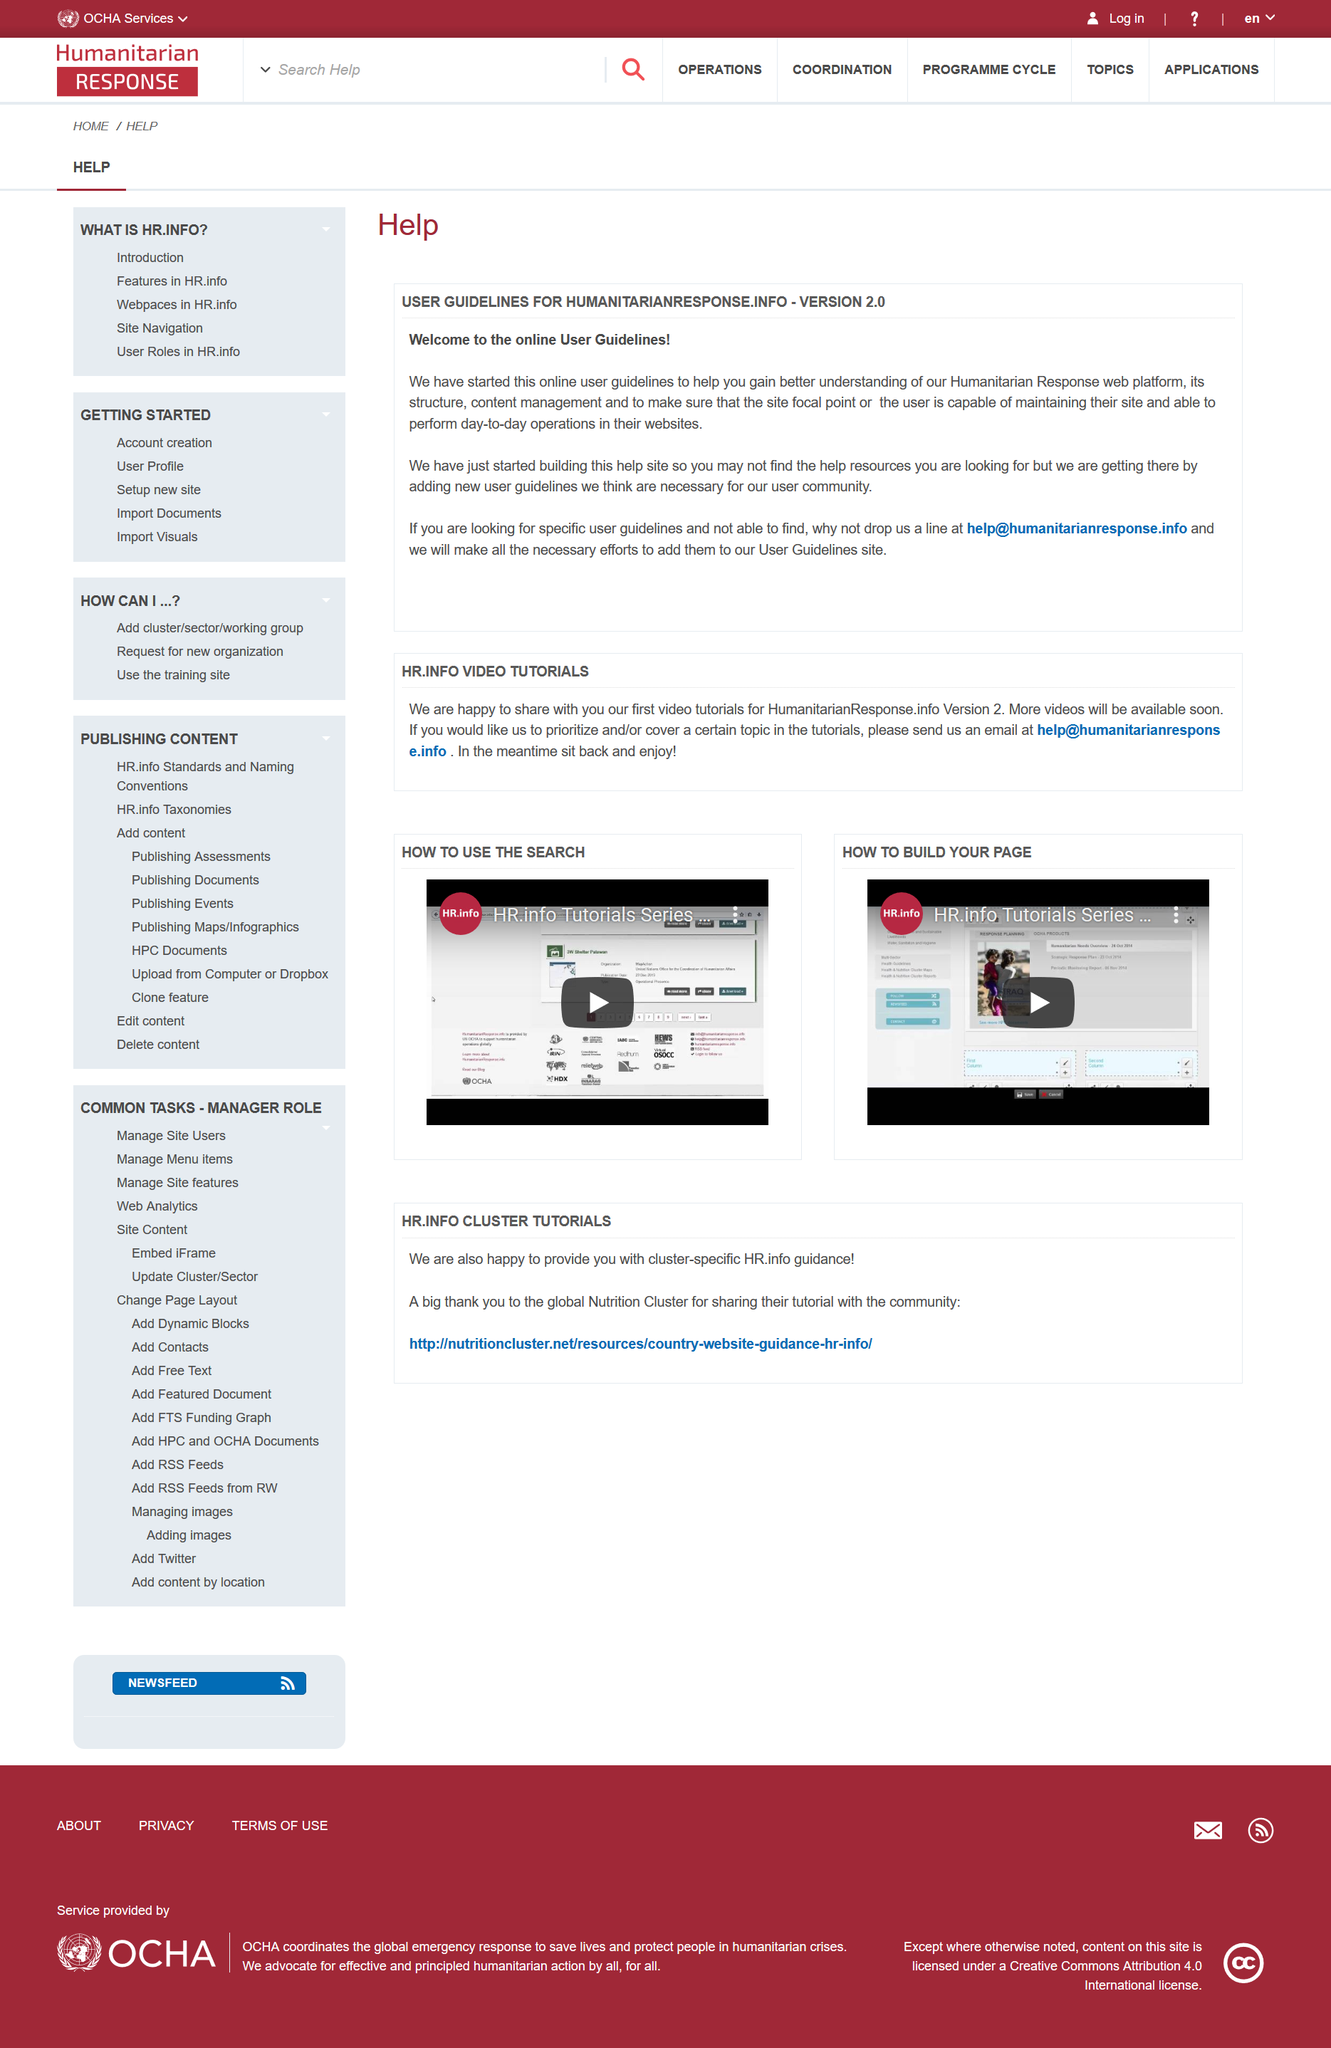Highlight a few significant elements in this photo. The user guidelines for humanitarianresponse.info are designed to help users better understand its structure and content management. The user guidelines for humanitarianresponse.info are not yet complete and finished. The humanitarianresponse.info user guidelines are specifically designed to facilitate the efficient and effective performance of daily operations on websites. 